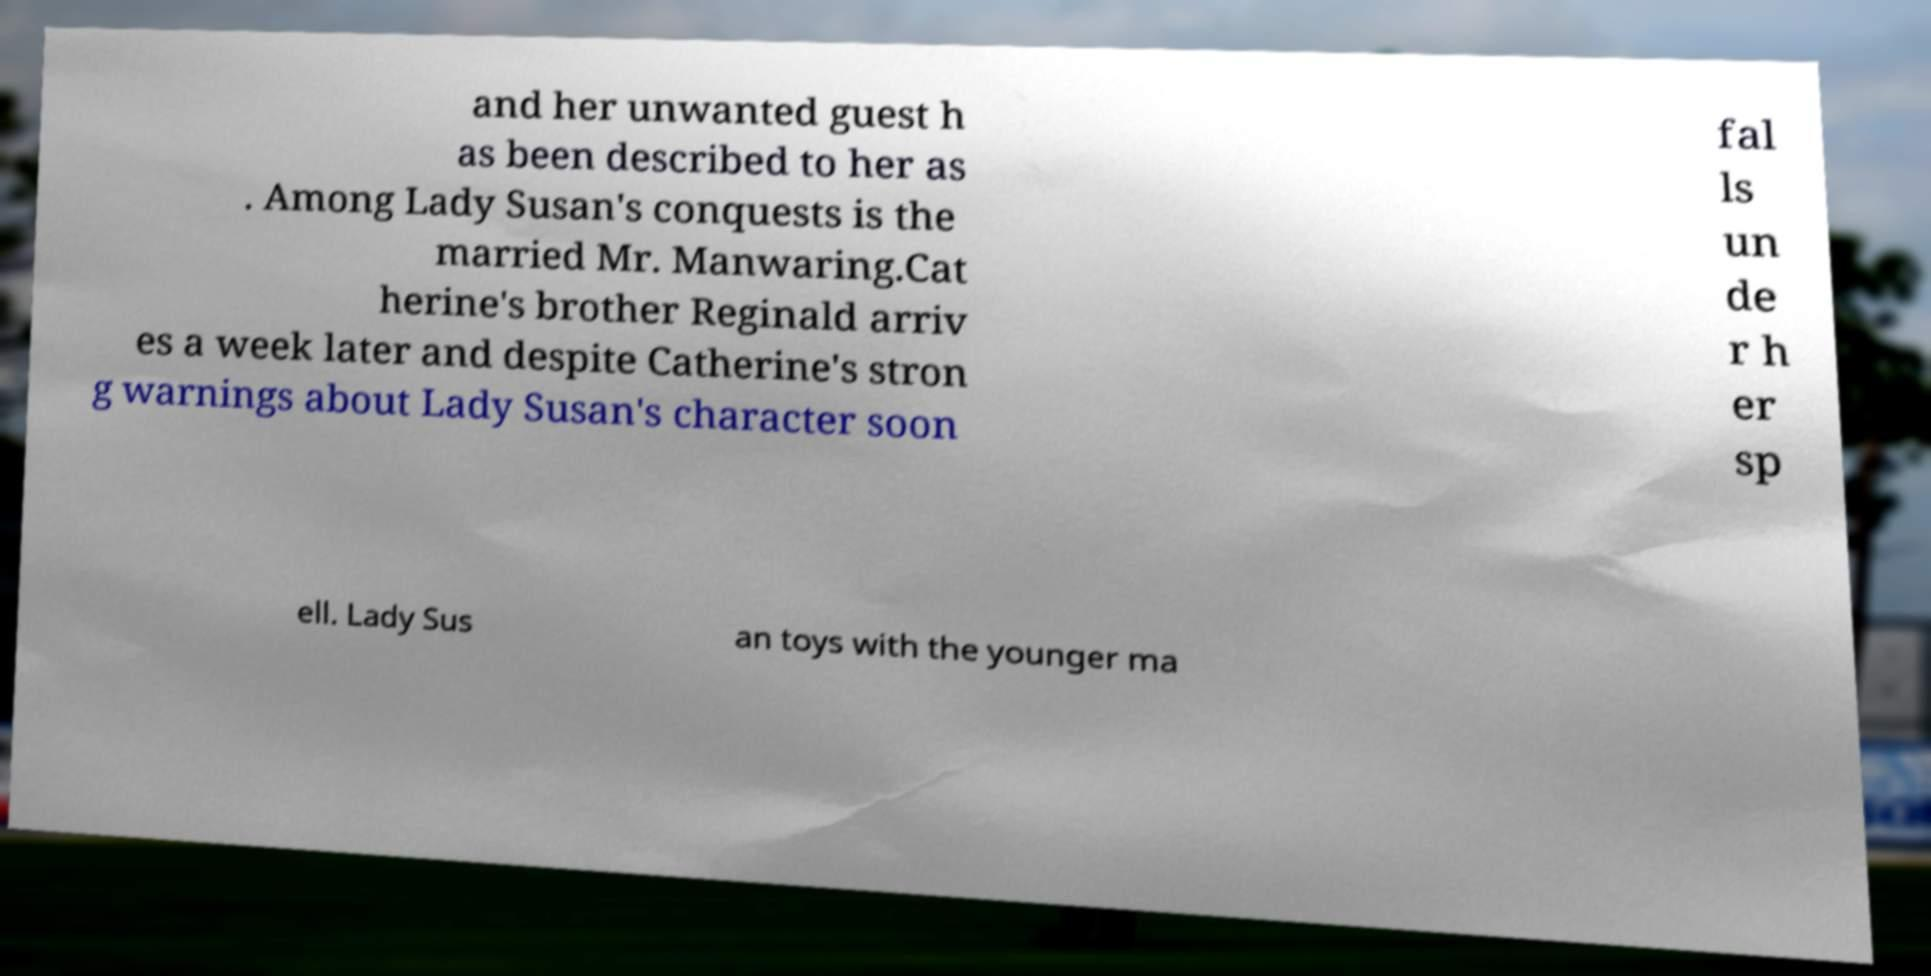For documentation purposes, I need the text within this image transcribed. Could you provide that? and her unwanted guest h as been described to her as . Among Lady Susan's conquests is the married Mr. Manwaring.Cat herine's brother Reginald arriv es a week later and despite Catherine's stron g warnings about Lady Susan's character soon fal ls un de r h er sp ell. Lady Sus an toys with the younger ma 